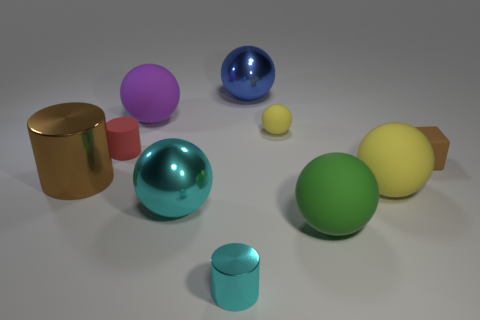There is another metal thing that is the same color as the tiny shiny object; what is its size?
Ensure brevity in your answer.  Large. Is the number of metallic objects that are behind the purple matte sphere greater than the number of large cyan objects that are on the right side of the big cyan shiny thing?
Your response must be concise. Yes. How many small rubber cubes have the same color as the large cylinder?
Offer a very short reply. 1. The cyan cylinder that is made of the same material as the blue sphere is what size?
Your answer should be compact. Small. How many objects are either yellow rubber things behind the small matte cube or tiny rubber spheres?
Offer a very short reply. 1. There is a large shiny thing that is on the left side of the big purple matte thing; is it the same color as the small block?
Keep it short and to the point. Yes. What is the size of the red thing that is the same shape as the large brown shiny thing?
Your answer should be compact. Small. There is a big shiny thing behind the tiny cube behind the cyan object behind the cyan metallic cylinder; what is its color?
Offer a very short reply. Blue. Is the cyan sphere made of the same material as the big blue thing?
Your response must be concise. Yes. Are there any big shiny cylinders behind the big metallic thing behind the metallic cylinder that is behind the tiny metal object?
Your response must be concise. No. 